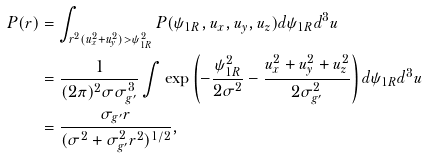Convert formula to latex. <formula><loc_0><loc_0><loc_500><loc_500>P ( r ) & = \int _ { r ^ { 2 } ( u _ { x } ^ { 2 } + u _ { y } ^ { 2 } ) > \psi _ { 1 R } ^ { 2 } } P ( \psi _ { 1 R } , u _ { x } , u _ { y } , u _ { z } ) d \psi _ { 1 R } d ^ { 3 } u \\ & = \frac { 1 } { ( 2 \pi ) ^ { 2 } \sigma \sigma _ { g ^ { \prime } } ^ { 3 } } \int \exp \left ( - \frac { \psi _ { 1 R } ^ { 2 } } { 2 \sigma ^ { 2 } } - \frac { u _ { x } ^ { 2 } + u _ { y } ^ { 2 } + u _ { z } ^ { 2 } } { 2 \sigma _ { g ^ { \prime } } ^ { 2 } } \right ) d \psi _ { 1 R } d ^ { 3 } u \\ & = \frac { \sigma _ { g ^ { \prime } } r } { ( \sigma ^ { 2 } + \sigma _ { g ^ { \prime } } ^ { 2 } r ^ { 2 } ) ^ { 1 / 2 } } ,</formula> 